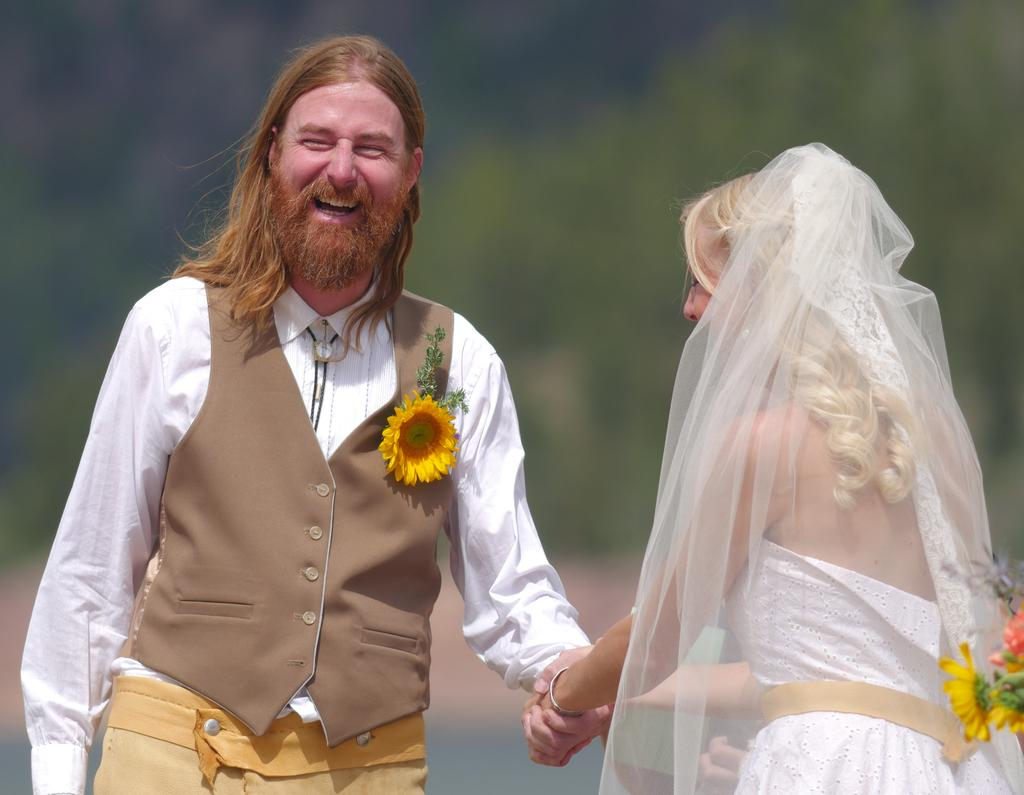How many people are in the image? There are two people in the image, a man and a woman. What are the man and woman doing in the image? The man and woman are holding hands in the image. Can you describe the man's appearance? The man has long hair. What can be seen in the background of the image? There are trees in the background of the image, but they are not clearly visible. What type of waste can be seen on the ground in the image? There is no waste visible on the ground in the image. Is the man in the image wearing a prison uniform? There is no indication in the image that the man is wearing a prison uniform or that he is in a prison setting. 